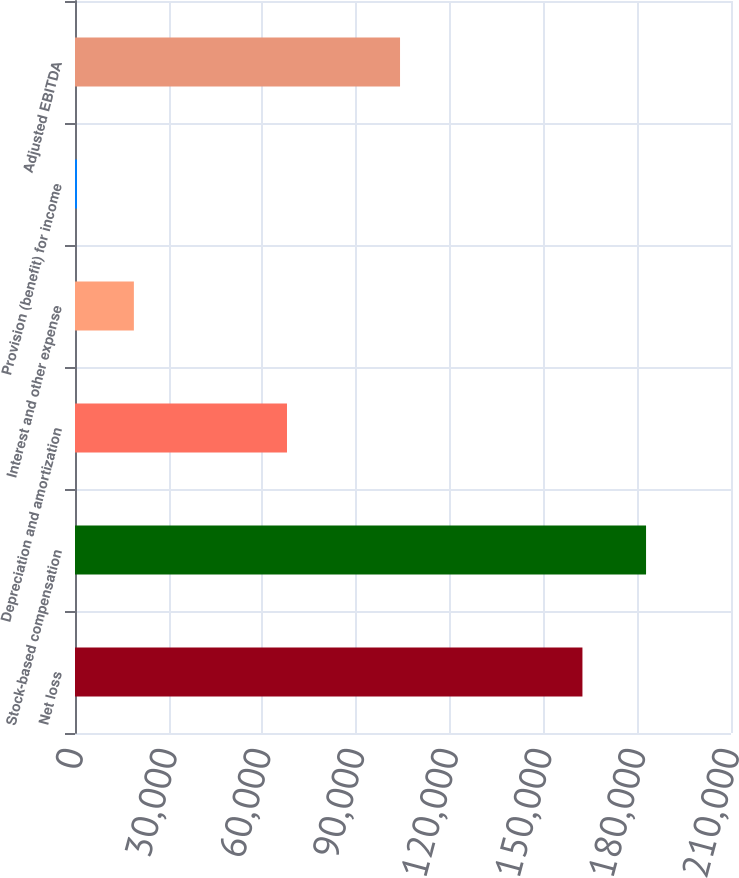<chart> <loc_0><loc_0><loc_500><loc_500><bar_chart><fcel>Net loss<fcel>Stock-based compensation<fcel>Depreciation and amortization<fcel>Interest and other expense<fcel>Provision (benefit) for income<fcel>Adjusted EBITDA<nl><fcel>162442<fcel>182805<fcel>67864<fcel>18849.3<fcel>632<fcel>104053<nl></chart> 